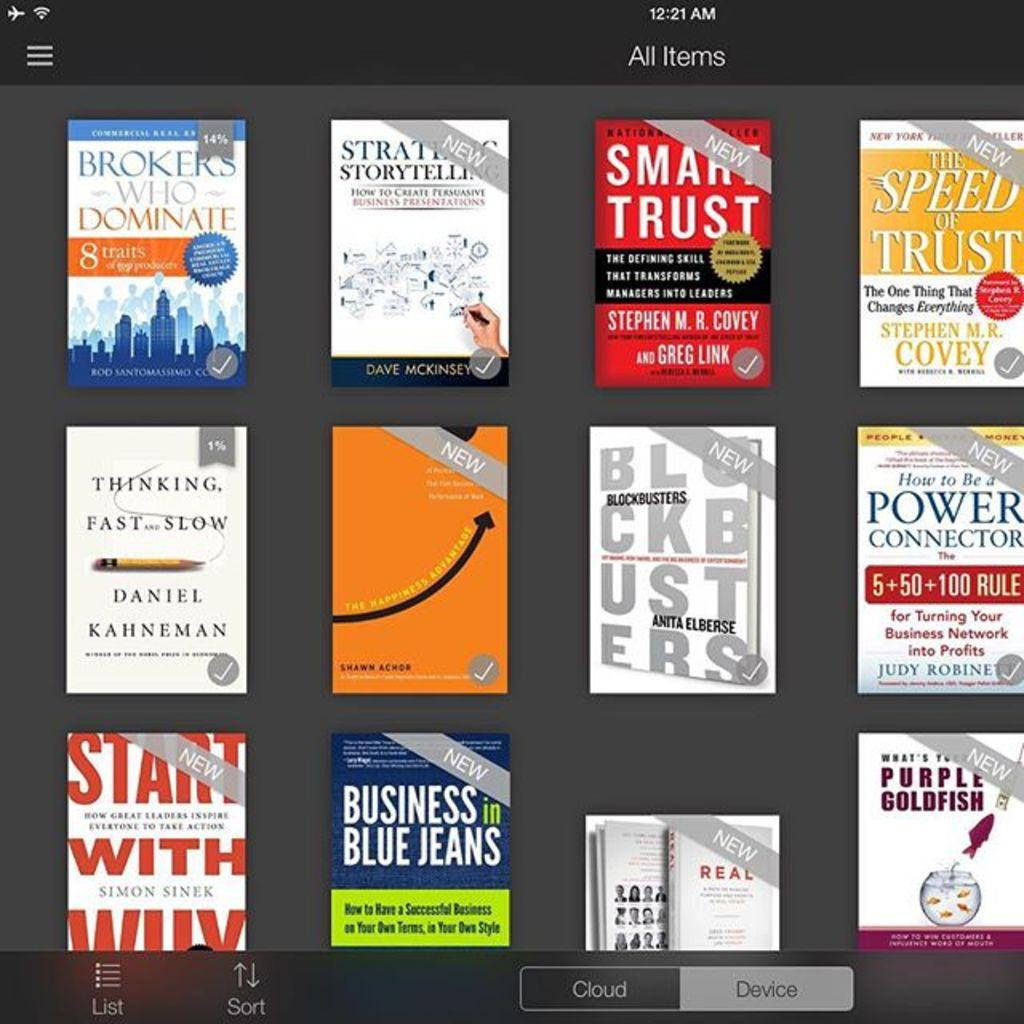<image>
Write a terse but informative summary of the picture. Several Ebooks like smart trust and business in blue jeans on a ebook app page. 